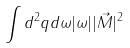Convert formula to latex. <formula><loc_0><loc_0><loc_500><loc_500>\int d ^ { 2 } q d \omega | \omega | | \vec { M } | ^ { 2 }</formula> 